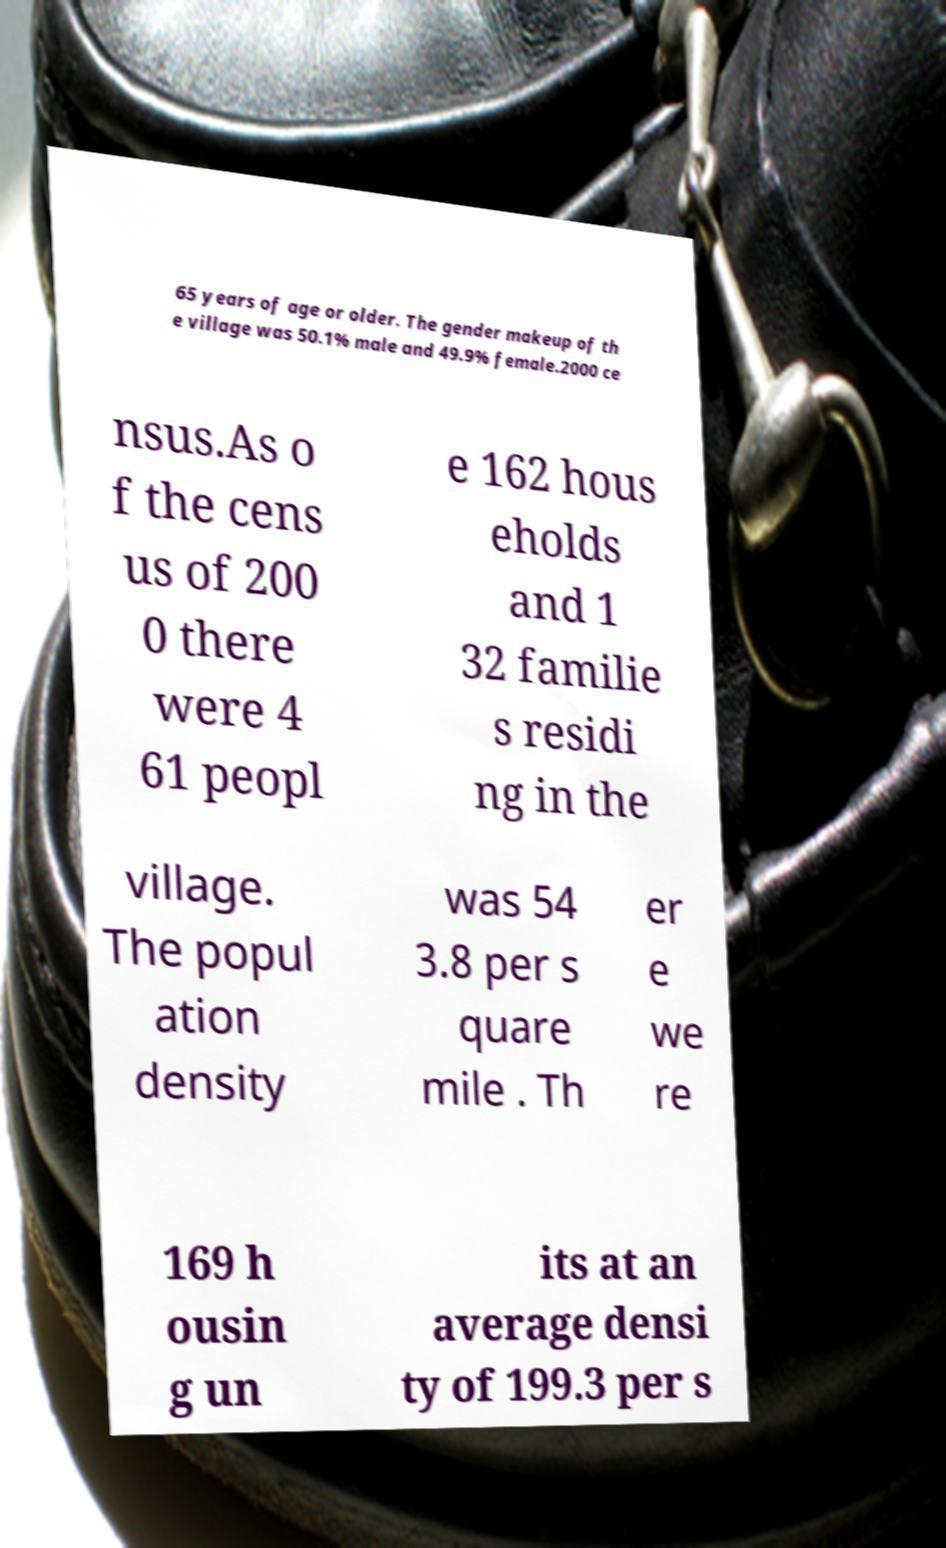Please identify and transcribe the text found in this image. 65 years of age or older. The gender makeup of th e village was 50.1% male and 49.9% female.2000 ce nsus.As o f the cens us of 200 0 there were 4 61 peopl e 162 hous eholds and 1 32 familie s residi ng in the village. The popul ation density was 54 3.8 per s quare mile . Th er e we re 169 h ousin g un its at an average densi ty of 199.3 per s 